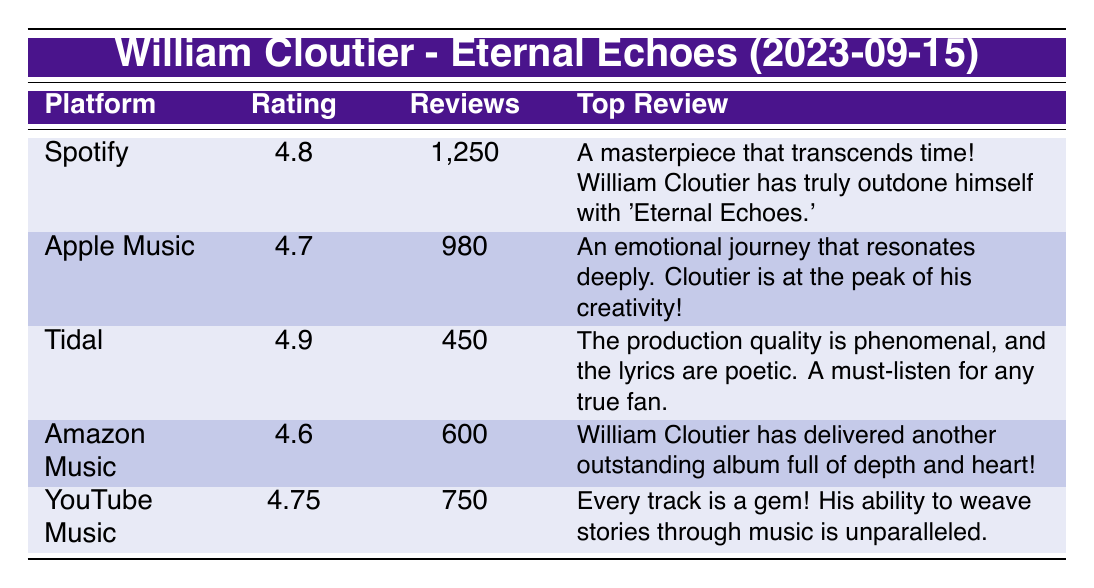What is the highest rating for William Cloutier's album on any platform? The highest rating in the table is found on Tidal with a rating of 4.9.
Answer: 4.9 Which platform has the most reviews for the album? Spotify has the most reviews listed in the table with a count of 1,250.
Answer: Spotify What is the average rating across all streaming platforms? To find the average rating, add all the ratings: 4.8 + 4.7 + 4.9 + 4.6 + 4.75 = 24.95. There are 5 platforms, so the average rating is 24.95 / 5 = 4.99.
Answer: 4.99 Is there a streaming platform where the rating is below 4.6? Yes, Amazon Music has a rating of 4.6, which is not below 4.6, but no platforms in the table have ratings below this threshold.
Answer: Yes Which platform has the least number of reviews for the album? The platform with the least number of reviews is Tidal, which has 450 reviews.
Answer: Tidal If you combine the reviews from Spotify and Apple Music, how many total reviews do they have? By adding the reviews from Spotify (1,250) and Apple Music (980), the total is 1,250 + 980 = 2,230 reviews.
Answer: 2,230 Did any platform have a top review that mentions creativity? Yes, the top review on Apple Music mentions "Cloutier is at the peak of his creativity!"
Answer: Yes What is the difference in ratings between the highest rated platform and the lowest? The highest rated platform is Tidal (4.9) and the lowest is Amazon Music (4.6). The difference is 4.9 - 4.6 = 0.3.
Answer: 0.3 